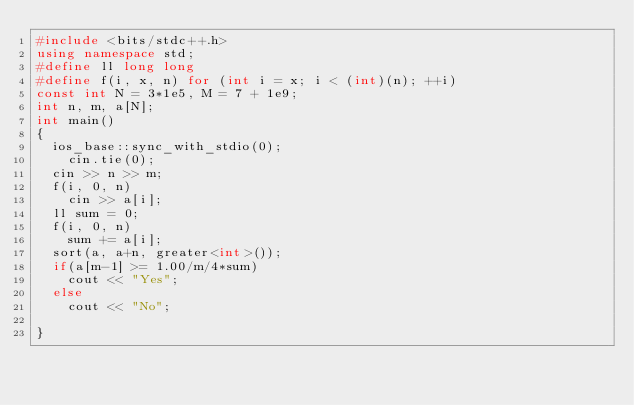<code> <loc_0><loc_0><loc_500><loc_500><_C++_>#include <bits/stdc++.h>
using namespace std;
#define ll long long
#define f(i, x, n) for (int i = x; i < (int)(n); ++i)
const int N = 3*1e5, M = 7 + 1e9;
int n, m, a[N];
int main()
{
	ios_base::sync_with_stdio(0);
   	cin.tie(0);
	cin >> n >> m;
	f(i, 0, n)
		cin >> a[i];
	ll sum = 0;
	f(i, 0, n)
		sum += a[i];
	sort(a, a+n, greater<int>());
	if(a[m-1] >= 1.00/m/4*sum)
		cout << "Yes";
	else
		cout << "No";
	
}</code> 